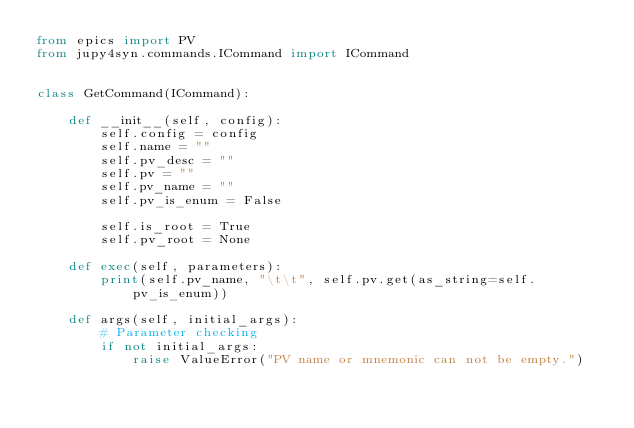<code> <loc_0><loc_0><loc_500><loc_500><_Python_>from epics import PV
from jupy4syn.commands.ICommand import ICommand


class GetCommand(ICommand):

    def __init__(self, config):
        self.config = config
        self.name = ""
        self.pv_desc = ""
        self.pv = ""
        self.pv_name = ""
        self.pv_is_enum = False

        self.is_root = True
        self.pv_root = None

    def exec(self, parameters):
        print(self.pv_name, "\t\t", self.pv.get(as_string=self.pv_is_enum))

    def args(self, initial_args):
        # Parameter checking
        if not initial_args:
            raise ValueError("PV name or mnemonic can not be empty.")</code> 